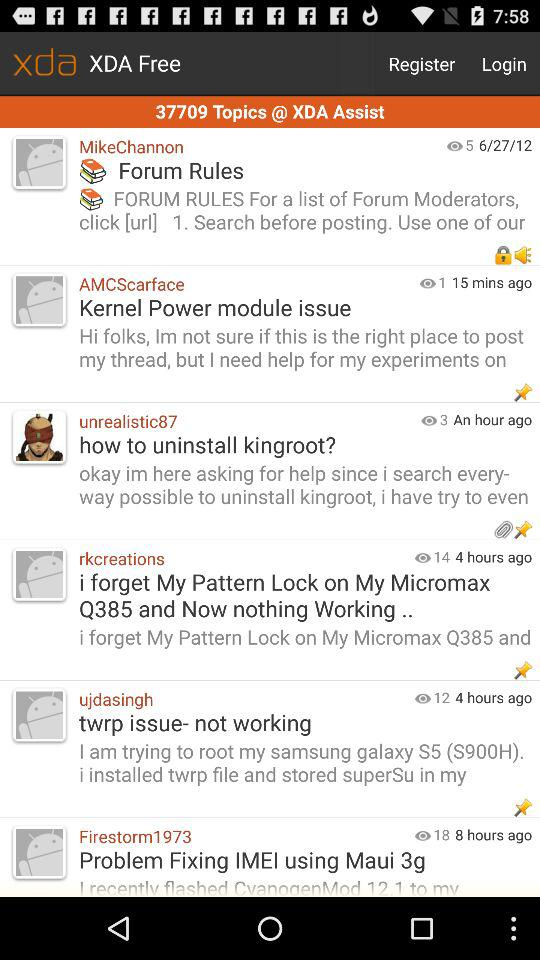What is the total number of topics covered in XDA Assist? The total number of topics covered in XDA Assist is 37709. 